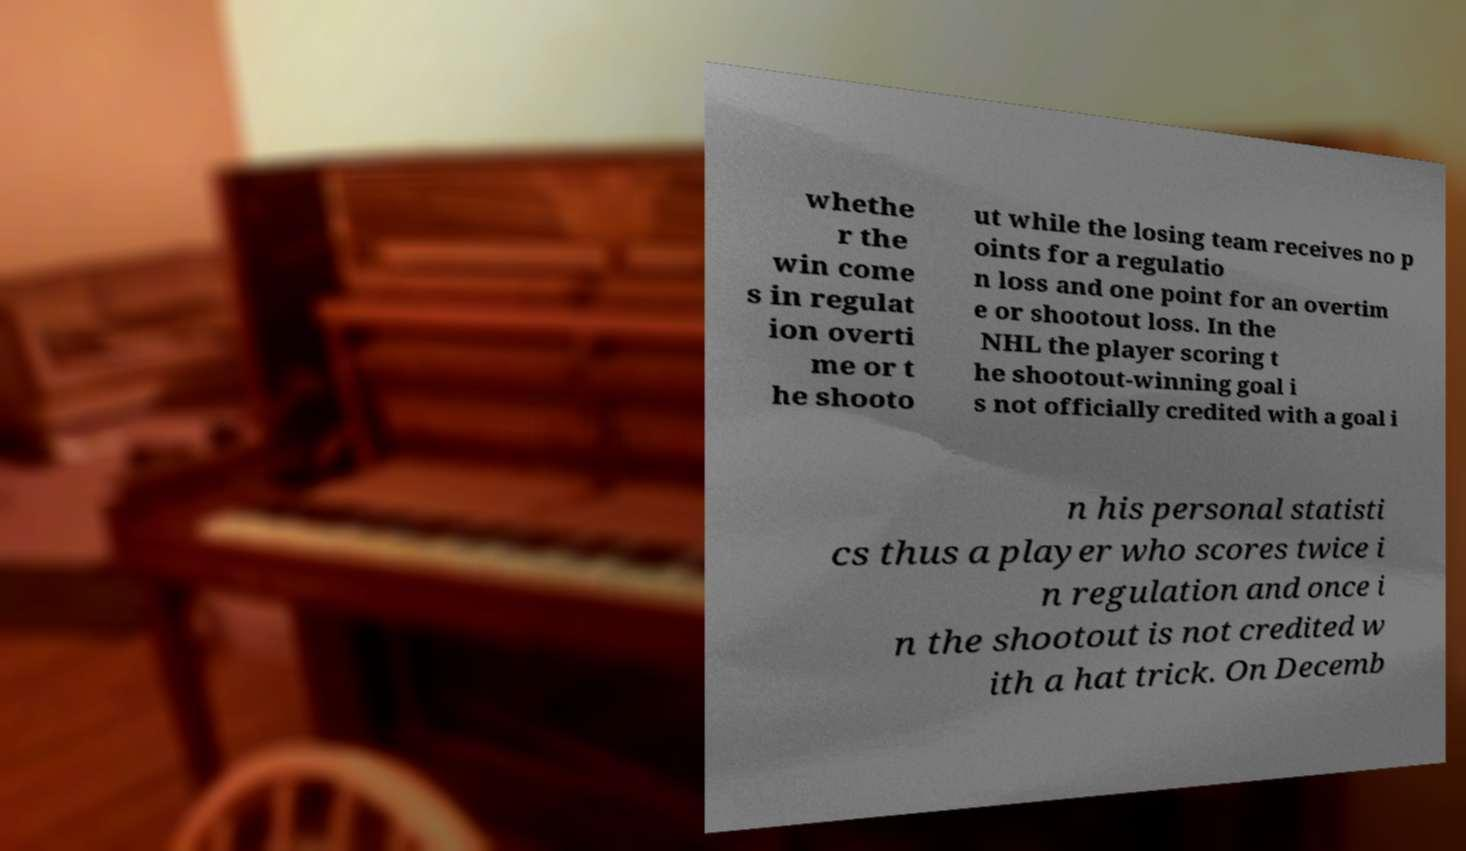Could you assist in decoding the text presented in this image and type it out clearly? whethe r the win come s in regulat ion overti me or t he shooto ut while the losing team receives no p oints for a regulatio n loss and one point for an overtim e or shootout loss. In the NHL the player scoring t he shootout-winning goal i s not officially credited with a goal i n his personal statisti cs thus a player who scores twice i n regulation and once i n the shootout is not credited w ith a hat trick. On Decemb 